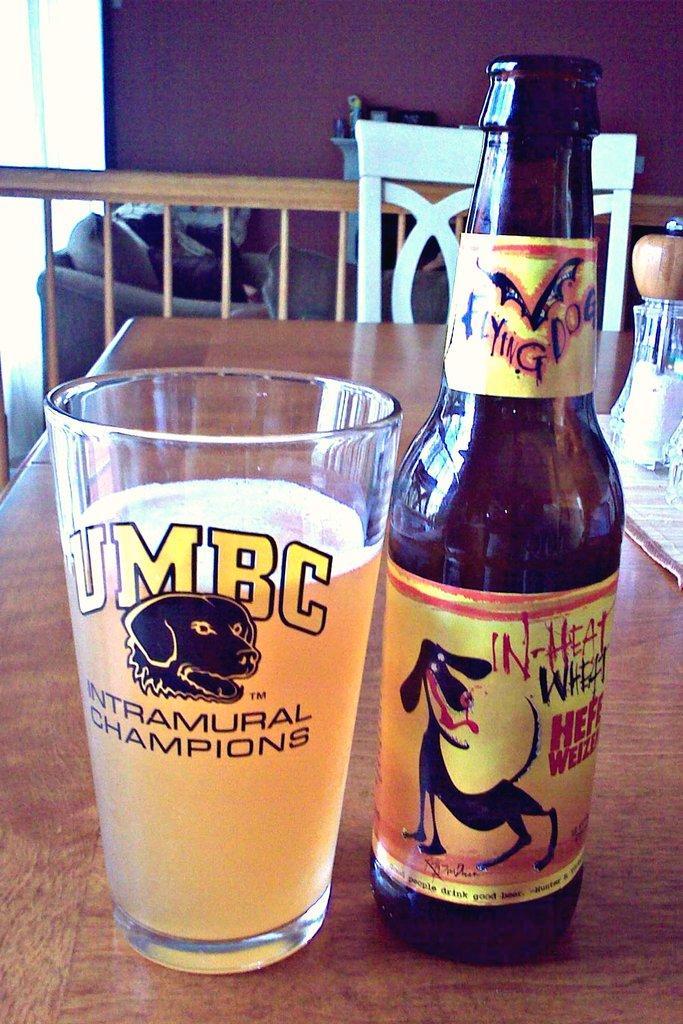In one or two sentences, can you explain what this image depicts? In this picture we can see a table. On the table there is a glass and bottle. Here we can see a chair and this is wall. 